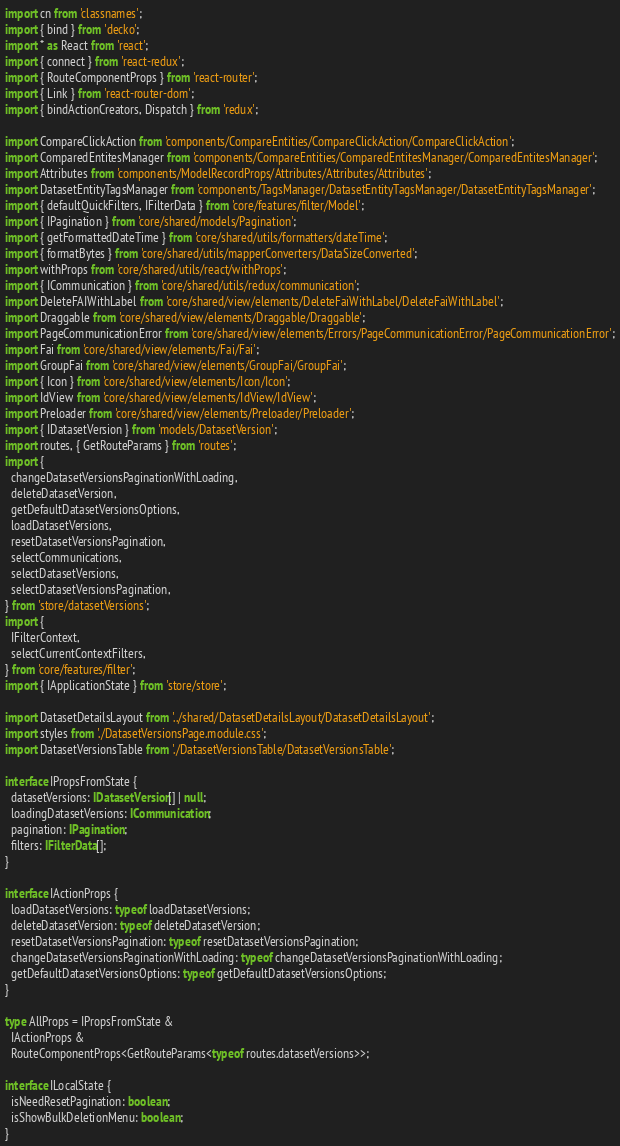Convert code to text. <code><loc_0><loc_0><loc_500><loc_500><_TypeScript_>import cn from 'classnames';
import { bind } from 'decko';
import * as React from 'react';
import { connect } from 'react-redux';
import { RouteComponentProps } from 'react-router';
import { Link } from 'react-router-dom';
import { bindActionCreators, Dispatch } from 'redux';

import CompareClickAction from 'components/CompareEntities/CompareClickAction/CompareClickAction';
import ComparedEntitesManager from 'components/CompareEntities/ComparedEntitesManager/ComparedEntitesManager';
import Attributes from 'components/ModelRecordProps/Attributes/Attributes/Attributes';
import DatasetEntityTagsManager from 'components/TagsManager/DatasetEntityTagsManager/DatasetEntityTagsManager';
import { defaultQuickFilters, IFilterData } from 'core/features/filter/Model';
import { IPagination } from 'core/shared/models/Pagination';
import { getFormattedDateTime } from 'core/shared/utils/formatters/dateTime';
import { formatBytes } from 'core/shared/utils/mapperConverters/DataSizeConverted';
import withProps from 'core/shared/utils/react/withProps';
import { ICommunication } from 'core/shared/utils/redux/communication';
import DeleteFAIWithLabel from 'core/shared/view/elements/DeleteFaiWithLabel/DeleteFaiWithLabel';
import Draggable from 'core/shared/view/elements/Draggable/Draggable';
import PageCommunicationError from 'core/shared/view/elements/Errors/PageCommunicationError/PageCommunicationError';
import Fai from 'core/shared/view/elements/Fai/Fai';
import GroupFai from 'core/shared/view/elements/GroupFai/GroupFai';
import { Icon } from 'core/shared/view/elements/Icon/Icon';
import IdView from 'core/shared/view/elements/IdView/IdView';
import Preloader from 'core/shared/view/elements/Preloader/Preloader';
import { IDatasetVersion } from 'models/DatasetVersion';
import routes, { GetRouteParams } from 'routes';
import {
  changeDatasetVersionsPaginationWithLoading,
  deleteDatasetVersion,
  getDefaultDatasetVersionsOptions,
  loadDatasetVersions,
  resetDatasetVersionsPagination,
  selectCommunications,
  selectDatasetVersions,
  selectDatasetVersionsPagination,
} from 'store/datasetVersions';
import {
  IFilterContext,
  selectCurrentContextFilters,
} from 'core/features/filter';
import { IApplicationState } from 'store/store';

import DatasetDetailsLayout from '../shared/DatasetDetailsLayout/DatasetDetailsLayout';
import styles from './DatasetVersionsPage.module.css';
import DatasetVersionsTable from './DatasetVersionsTable/DatasetVersionsTable';

interface IPropsFromState {
  datasetVersions: IDatasetVersion[] | null;
  loadingDatasetVersions: ICommunication;
  pagination: IPagination;
  filters: IFilterData[];
}

interface IActionProps {
  loadDatasetVersions: typeof loadDatasetVersions;
  deleteDatasetVersion: typeof deleteDatasetVersion;
  resetDatasetVersionsPagination: typeof resetDatasetVersionsPagination;
  changeDatasetVersionsPaginationWithLoading: typeof changeDatasetVersionsPaginationWithLoading;
  getDefaultDatasetVersionsOptions: typeof getDefaultDatasetVersionsOptions;
}

type AllProps = IPropsFromState &
  IActionProps &
  RouteComponentProps<GetRouteParams<typeof routes.datasetVersions>>;

interface ILocalState {
  isNeedResetPagination: boolean;
  isShowBulkDeletionMenu: boolean;
}
</code> 